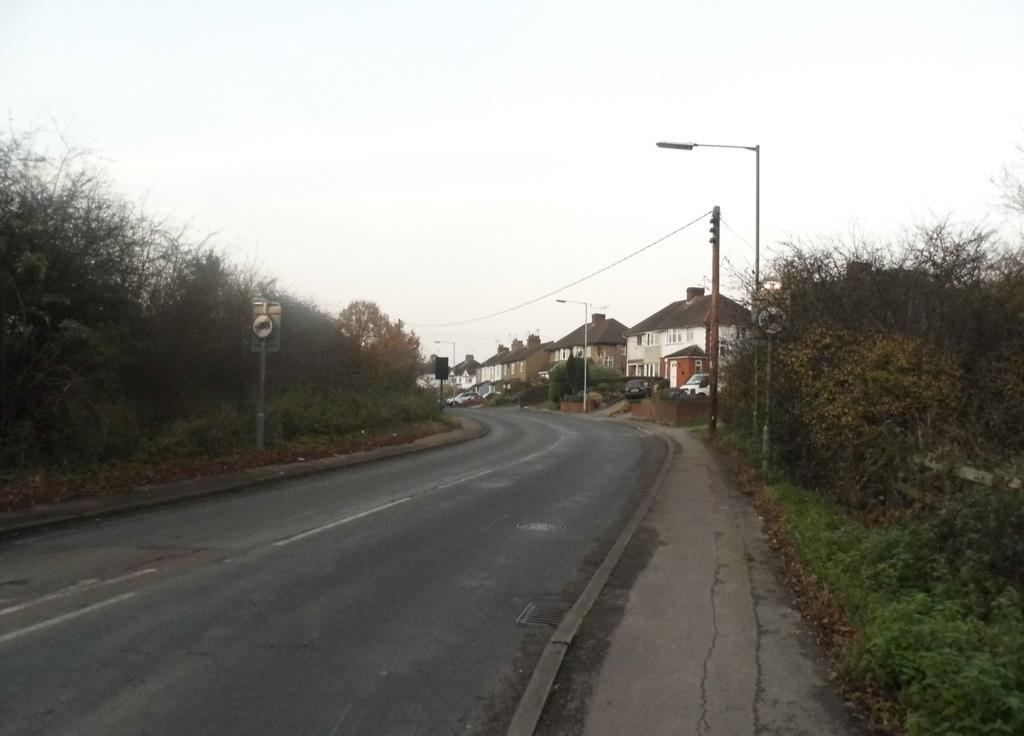Could you give a brief overview of what you see in this image? There is a road. On the side of the road there are sidewalks. Also there are trees, sign board with pole, street light poles and electric pole. In the background there are buildings, vehicles and sky. 